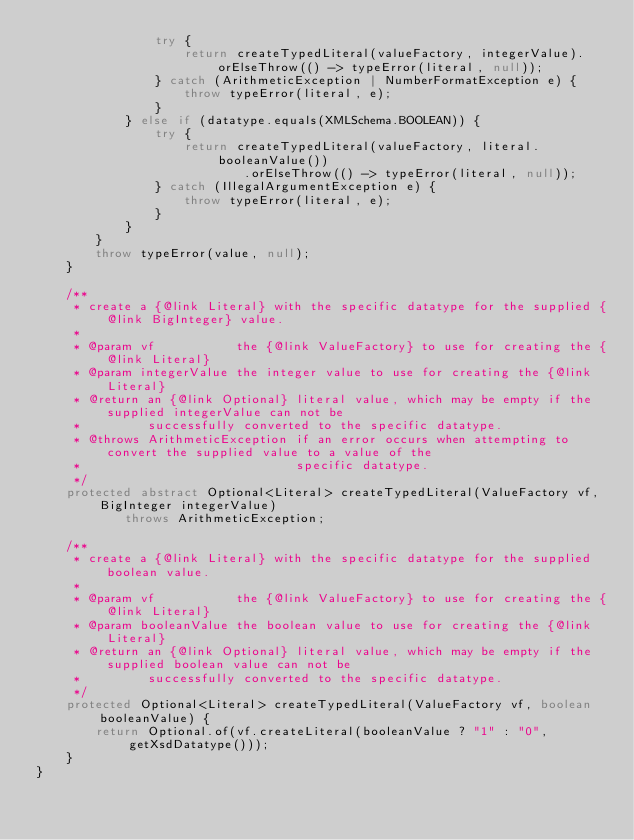Convert code to text. <code><loc_0><loc_0><loc_500><loc_500><_Java_>				try {
					return createTypedLiteral(valueFactory, integerValue).orElseThrow(() -> typeError(literal, null));
				} catch (ArithmeticException | NumberFormatException e) {
					throw typeError(literal, e);
				}
			} else if (datatype.equals(XMLSchema.BOOLEAN)) {
				try {
					return createTypedLiteral(valueFactory, literal.booleanValue())
							.orElseThrow(() -> typeError(literal, null));
				} catch (IllegalArgumentException e) {
					throw typeError(literal, e);
				}
			}
		}
		throw typeError(value, null);
	}

	/**
	 * create a {@link Literal} with the specific datatype for the supplied {@link BigInteger} value.
	 * 
	 * @param vf           the {@link ValueFactory} to use for creating the {@link Literal}
	 * @param integerValue the integer value to use for creating the {@link Literal}
	 * @return an {@link Optional} literal value, which may be empty if the supplied integerValue can not be
	 *         successfully converted to the specific datatype.
	 * @throws ArithmeticException if an error occurs when attempting to convert the supplied value to a value of the
	 *                             specific datatype.
	 */
	protected abstract Optional<Literal> createTypedLiteral(ValueFactory vf, BigInteger integerValue)
			throws ArithmeticException;

	/**
	 * create a {@link Literal} with the specific datatype for the supplied boolean value.
	 * 
	 * @param vf           the {@link ValueFactory} to use for creating the {@link Literal}
	 * @param booleanValue the boolean value to use for creating the {@link Literal}
	 * @return an {@link Optional} literal value, which may be empty if the supplied boolean value can not be
	 *         successfully converted to the specific datatype.
	 */
	protected Optional<Literal> createTypedLiteral(ValueFactory vf, boolean booleanValue) {
		return Optional.of(vf.createLiteral(booleanValue ? "1" : "0", getXsdDatatype()));
	}
}
</code> 